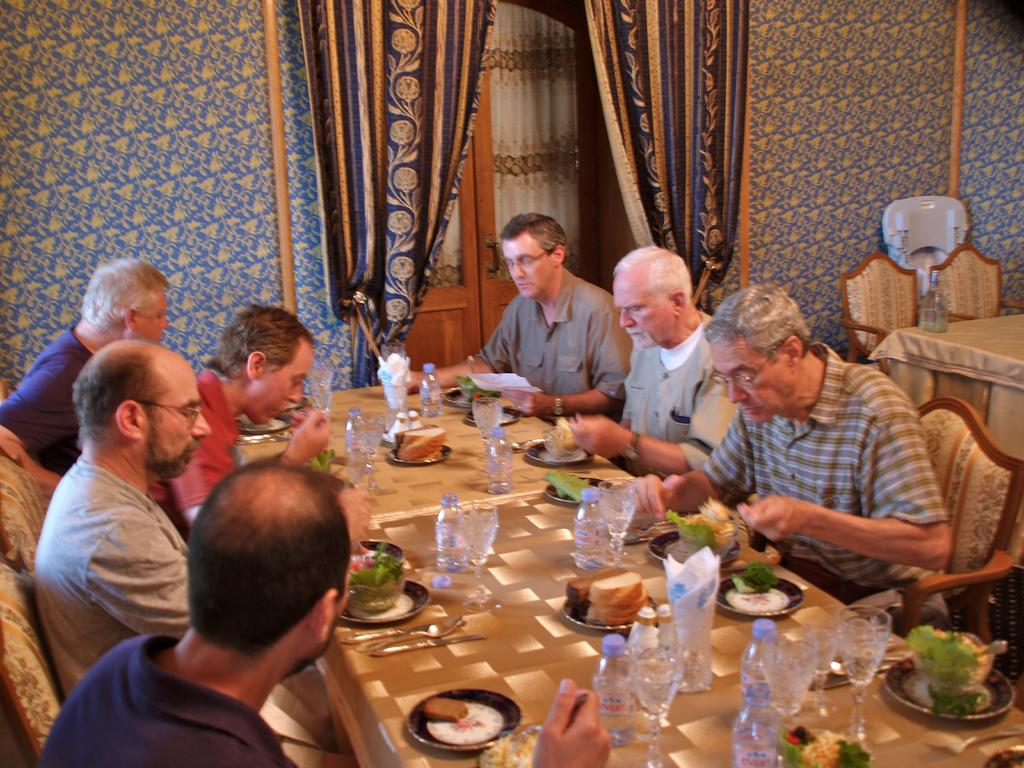How many people are in the image? There is a group of people in the image. What are the people doing in the image? The people are sitting on chairs. Where are the chairs located in relation to the table? The chairs are in front of a table. What can be seen on the table in the image? There are glass bottles, glasses, plates, and other objects on the table. What type of park can be seen in the image? There is no park present in the image; it features a group of people sitting in front of a table with various objects. How does the group of people feel about the objects on the table? The image does not convey the emotions or beliefs of the people, so it cannot be determined how they feel about the objects on the table. 